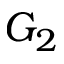<formula> <loc_0><loc_0><loc_500><loc_500>G _ { 2 }</formula> 